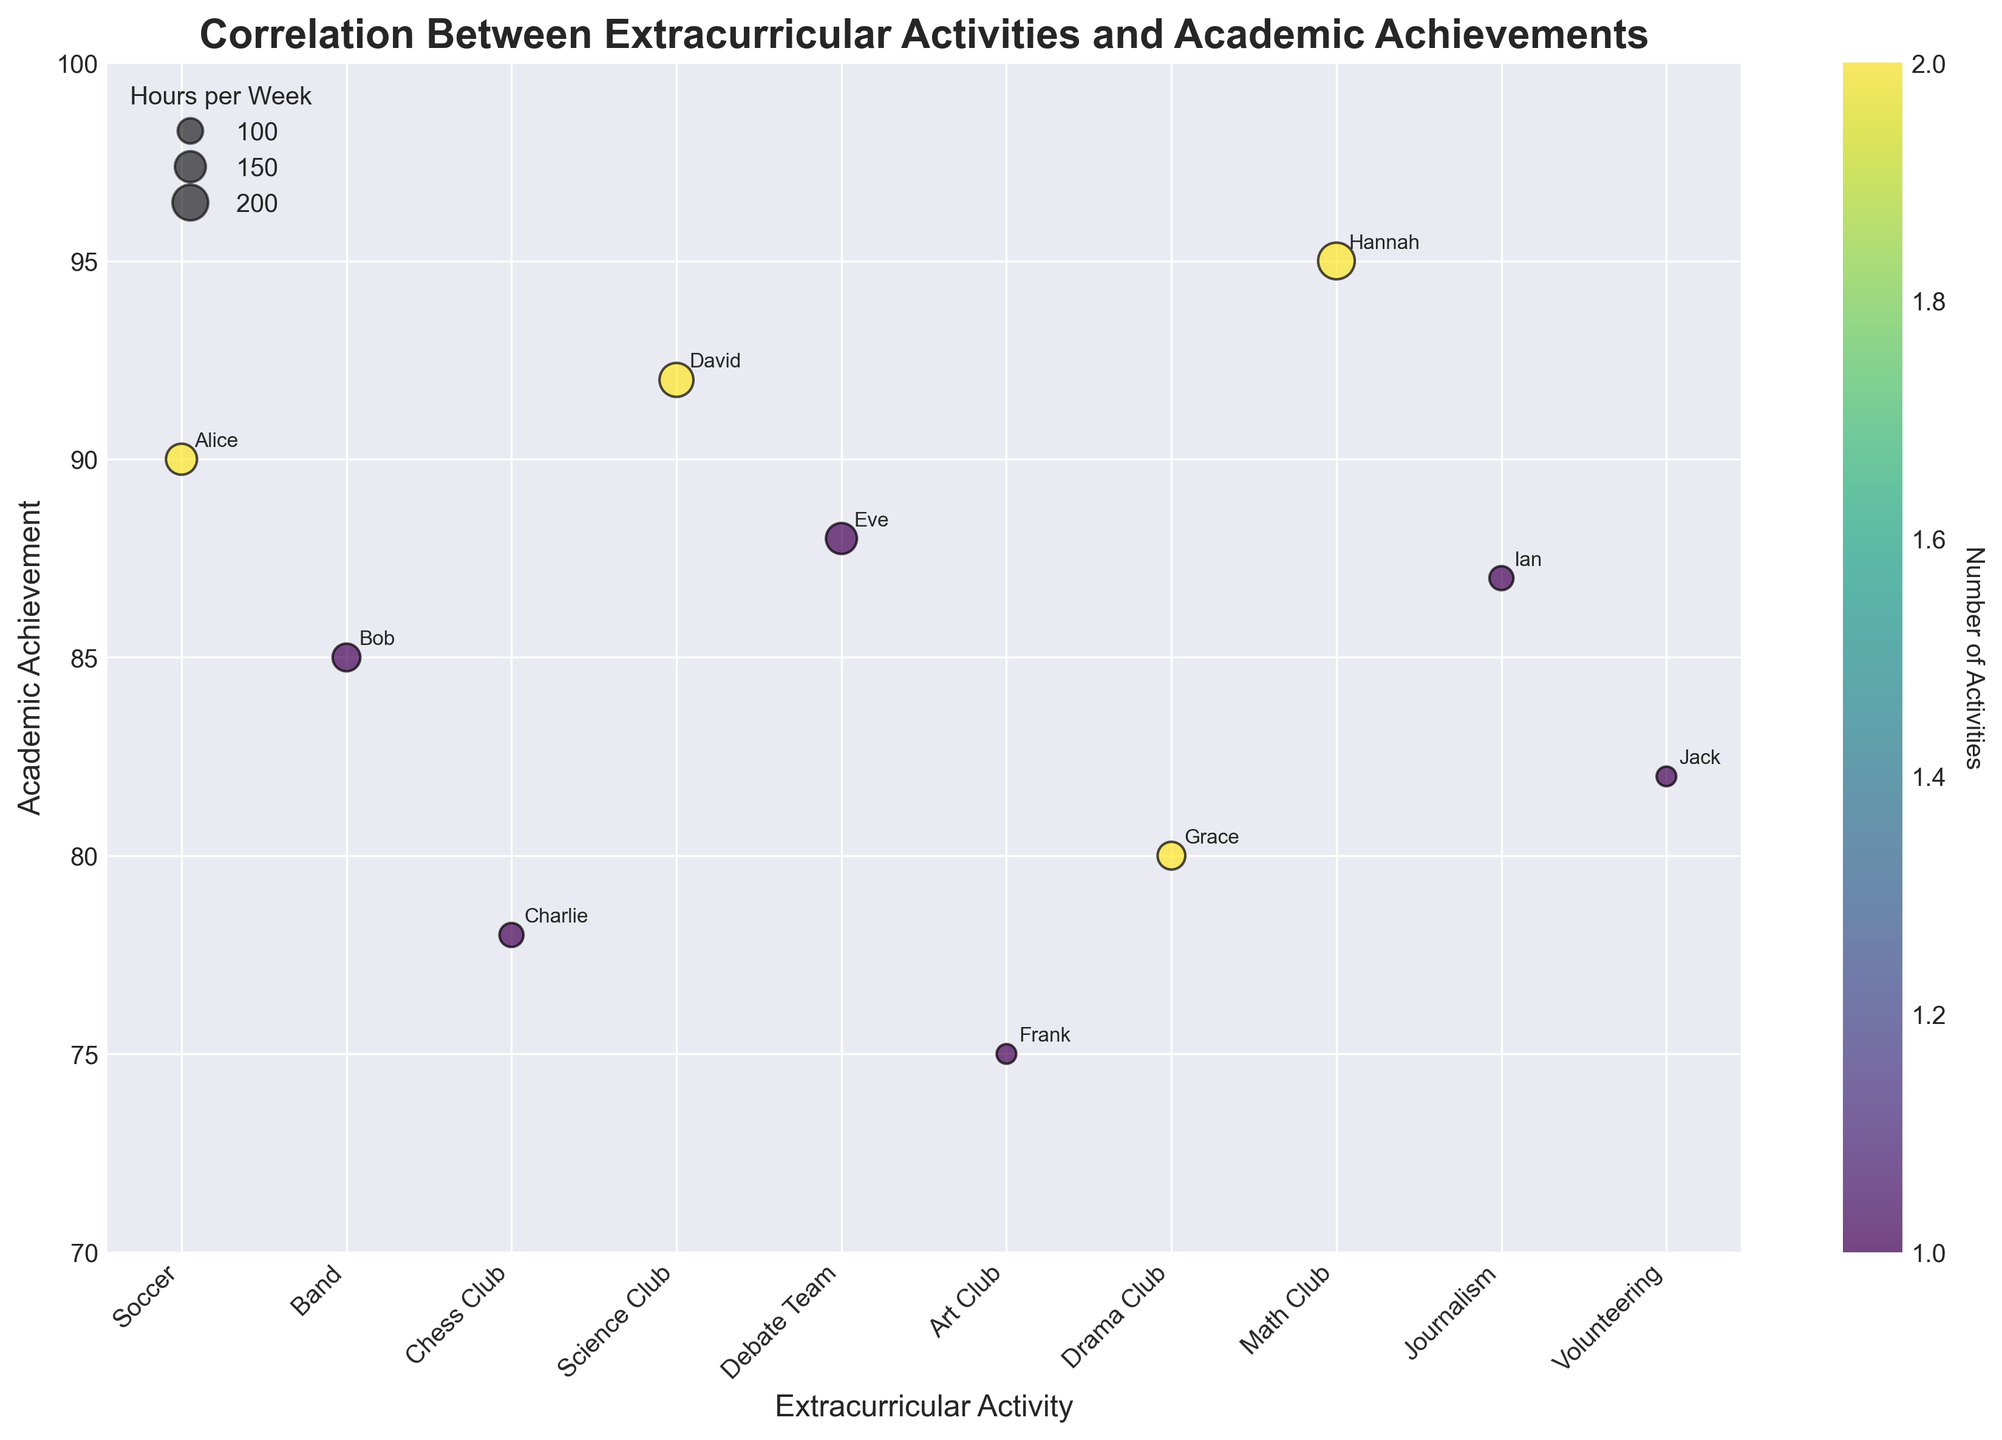What is the title of the plot? The title is displayed at the top of the plot.
Answer: Correlation Between Extracurricular Activities and Academic Achievements What are the x and y axes representing in this chart? The x-axis is labeled 'Extracurricular Activity' and the y-axis is labeled 'Academic Achievement'.
Answer: Extracurricular Activity, Academic Achievement How many students participate in the Math Club? Look at the number of bubbles aligned with 'Math Club' on the x-axis. There is one bubble indicated by the point labeled 'Hannah'.
Answer: One Which student spends the most hours per week on their extracurricular activity? Identify the bubble with the largest size on the chart and check the label attached to it. Hannah's bubble is the largest.
Answer: Hannah Which extracurricular activity has the lowest average academic achievement? Identify the bubbles grouped under one activity on the x-axis and average their y-axis positions (Academic Achievement). Art Club has Frank with the lowest value of 75.
Answer: Art Club What is the color gradient representing on the chart? Examine the color bar (legend) on the right side that aligns with the bubbles on the plot. It indicates the number of activities.
Answer: Number of Activities What is the academic achievement and extracurricular activity of the student who participates in chess club? Locate the 'Chess Club' label on the x-axis and check the corresponding bubble's y-position and label beside it. The bubble is labeled 'Charlie' and the score is around 78.
Answer: 78, Chess Club Compare the academic achievement of students who are in Science Club and Math Club. Which one is higher? Locate the bubbles under 'Science Club' and 'Math Club' on the x-axis, then compare their y-axis positions. David from Science Club has 92, and Hannah from Math Club has 95. The Math Club has a higher value.
Answer: Math Club Calculate the average academic achievement of students involved in two extracurricular activities. Identify students involved in two activities from the color gradient (number of activities=2) and average their y-axis values. Students are Alice (90), David (92), Grace (80), Hannah (95). Average is (90+92+80+95)/4 = 89.25
Answer: 89.25 What is the range of academic achievements shown in the plot? Find the minimum and maximum y-values for all bubbles. The lowest is Frank with 75 and the highest is Hannah with 95, so the range is 95 - 75.
Answer: 20 